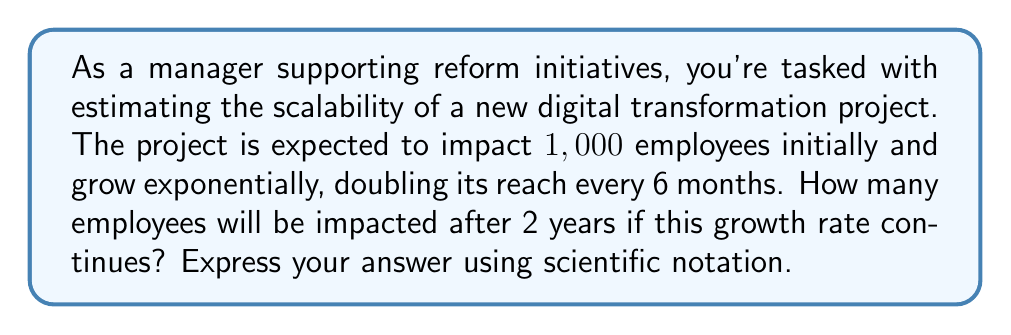Provide a solution to this math problem. Let's approach this step-by-step:

1) First, we need to identify the key components of our exponential function:
   - Initial value: $a = 1,000$ employees
   - Growth rate: doubles every 6 months, so $r = 2$ for each period
   - Time: 2 years = 4 periods of 6 months each

2) The general form of an exponential function is:

   $$ y = a \cdot r^t $$

   Where $y$ is the final value, $a$ is the initial value, $r$ is the growth rate, and $t$ is the number of time periods.

3) Plugging in our values:

   $$ y = 1,000 \cdot 2^4 $$

4) Let's calculate $2^4$:
   
   $$ 2^4 = 2 \cdot 2 \cdot 2 \cdot 2 = 16 $$

5) Now our equation looks like:

   $$ y = 1,000 \cdot 16 = 16,000 $$

6) To express this in scientific notation, we move the decimal point 4 places to the left:

   $$ 16,000 = 1.6 \times 10^4 $$

Thus, after 2 years, the reform initiative will impact $1.6 \times 10^4$ employees.
Answer: $1.6 \times 10^4$ employees 